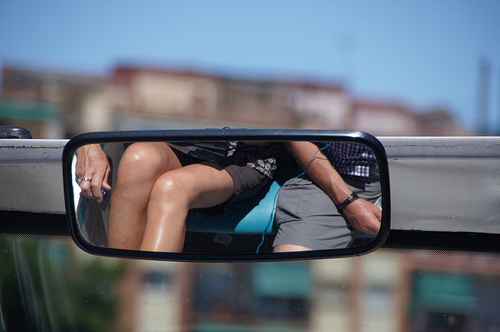<image>
Is there a man in the mirror? Yes. The man is contained within or inside the mirror, showing a containment relationship. 